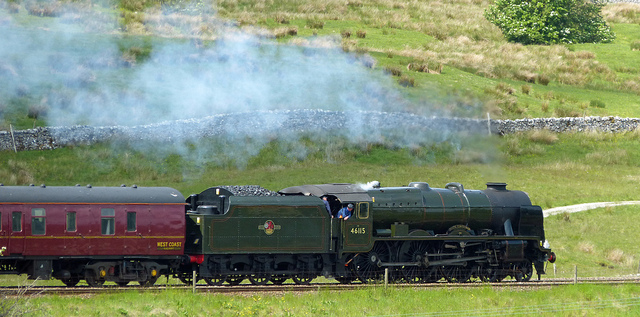Please transcribe the text in this image. 46115 